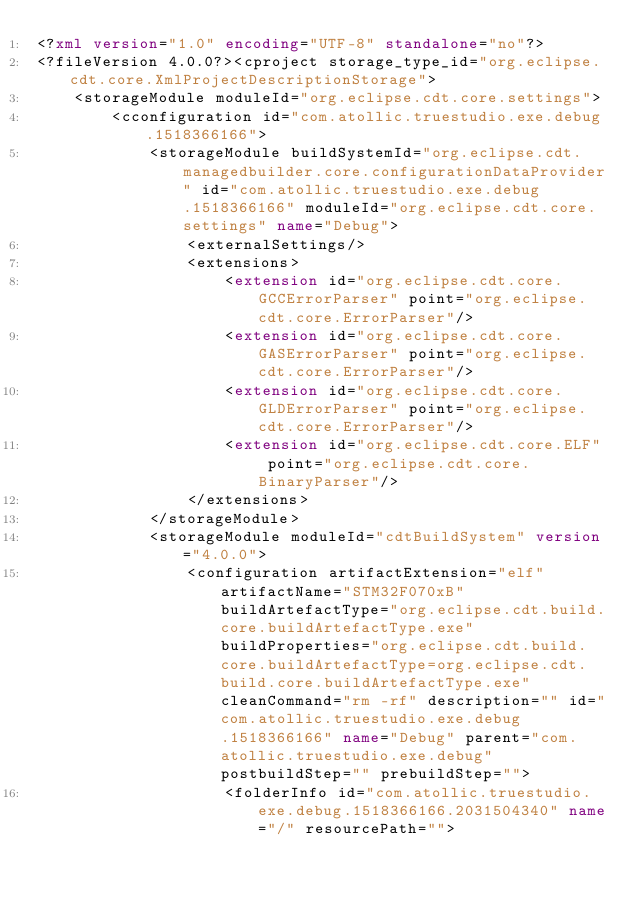Convert code to text. <code><loc_0><loc_0><loc_500><loc_500><_XML_><?xml version="1.0" encoding="UTF-8" standalone="no"?>
<?fileVersion 4.0.0?><cproject storage_type_id="org.eclipse.cdt.core.XmlProjectDescriptionStorage">
	<storageModule moduleId="org.eclipse.cdt.core.settings">
		<cconfiguration id="com.atollic.truestudio.exe.debug.1518366166">
			<storageModule buildSystemId="org.eclipse.cdt.managedbuilder.core.configurationDataProvider" id="com.atollic.truestudio.exe.debug.1518366166" moduleId="org.eclipse.cdt.core.settings" name="Debug">
				<externalSettings/>
				<extensions>
					<extension id="org.eclipse.cdt.core.GCCErrorParser" point="org.eclipse.cdt.core.ErrorParser"/>
					<extension id="org.eclipse.cdt.core.GASErrorParser" point="org.eclipse.cdt.core.ErrorParser"/>
					<extension id="org.eclipse.cdt.core.GLDErrorParser" point="org.eclipse.cdt.core.ErrorParser"/>
					<extension id="org.eclipse.cdt.core.ELF" point="org.eclipse.cdt.core.BinaryParser"/>
				</extensions>
			</storageModule>
			<storageModule moduleId="cdtBuildSystem" version="4.0.0">
				<configuration artifactExtension="elf" artifactName="STM32F070xB" buildArtefactType="org.eclipse.cdt.build.core.buildArtefactType.exe" buildProperties="org.eclipse.cdt.build.core.buildArtefactType=org.eclipse.cdt.build.core.buildArtefactType.exe" cleanCommand="rm -rf" description="" id="com.atollic.truestudio.exe.debug.1518366166" name="Debug" parent="com.atollic.truestudio.exe.debug" postbuildStep="" prebuildStep="">
					<folderInfo id="com.atollic.truestudio.exe.debug.1518366166.2031504340" name="/" resourcePath=""></code> 